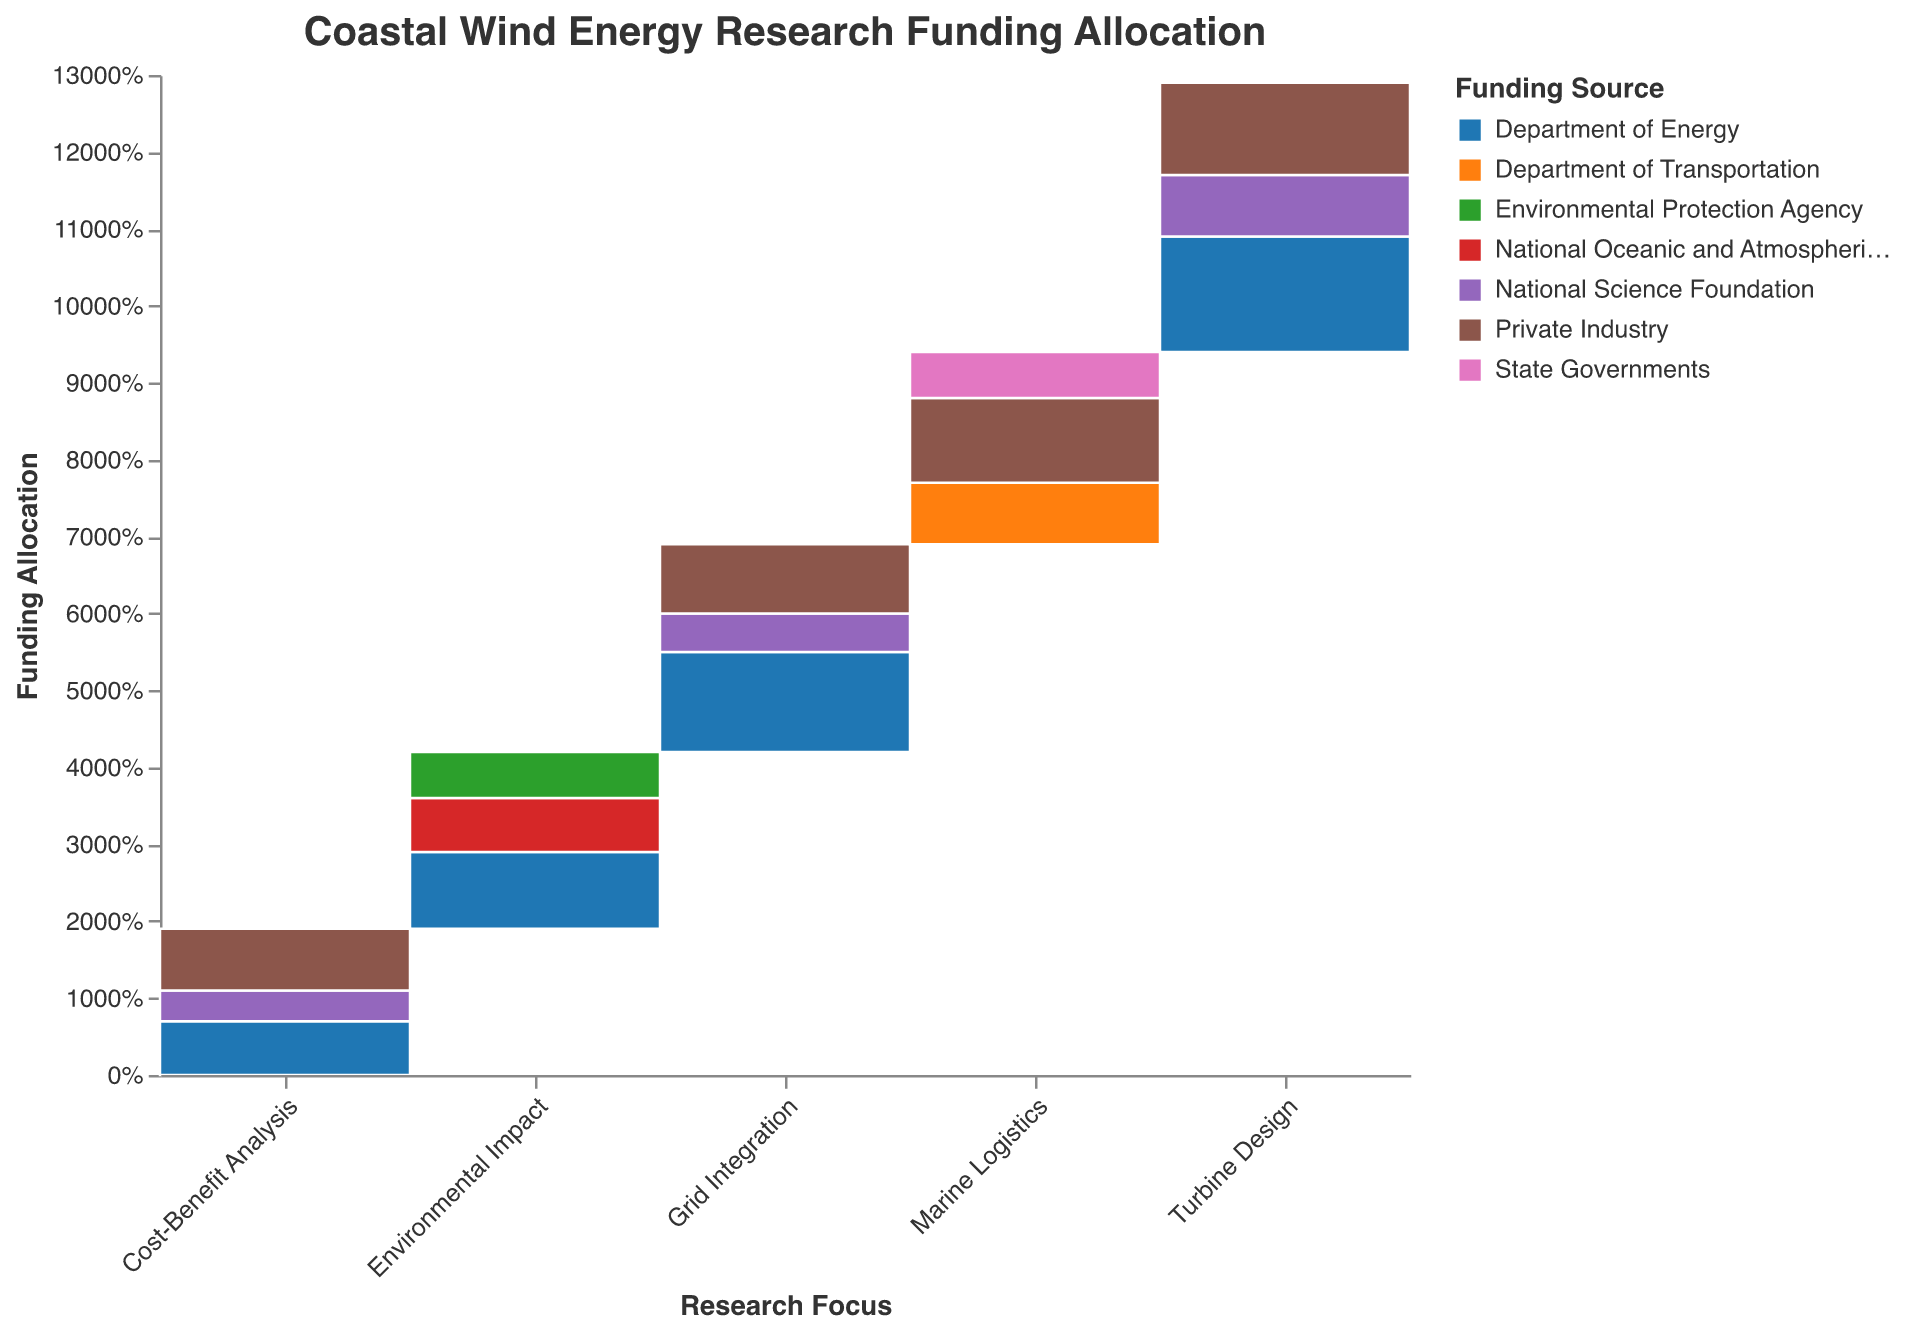What is the title of the plot? The title of the plot is typically located at the top of the visualization and provides a summary of the plot's content. In this case, it reads "Coastal Wind Energy Research Funding Allocation".
Answer: Coastal Wind Energy Research Funding Allocation Which funding source contributes the most to Turbine Design? Look for the largest segment within the "Turbine Design" category. The largest segment is "Department of Energy" with 15 million USD.
Answer: Department of Energy What proportion of the funding for Environmental Impact comes from the National Oceanic and Atmospheric Administration? Identify the segment corresponding to the National Oceanic and Atmospheric Administration in the Environmental Impact category and refer to the tooltip or stacked bar height. It is 7 out of 23 million USD, which is approximately 30.4%.
Answer: 30.4% Compare the total funding for Grid Integration and Marine Logistics. Which has more? Sum the funding amounts for each research focus. Grid Integration totals 27 million USD (13 + 5 + 9), and Marine Logistics totals 25 million USD (8 + 11 + 6). Therefore, Grid Integration has more funding.
Answer: Grid Integration How does the Department of Energy's funding allocation vary across different research focuses? Look for the segments corresponding to the Department of Energy for each research focus and compare their sizes. For example, it is the largest for Turbine Design and also makes substantial contributions to Environmental Impact, Grid Integration, and Cost-Benefit Analysis.
Answer: It varies but is dominant in Turbine Design, significant in Environmental Impact and Grid Integration, and notable in Cost-Benefit Analysis What is the smallest funding allocation within the Cost-Benefit Analysis research focus? Look for the smallest segment within the Cost-Benefit Analysis category. The smallest segment is the National Science Foundation with 4 million USD.
Answer: National Science Foundation Which research focus has the highest total funding allocation from Private Industry? Compare the sum of funding amounts from Private Industry for each research focus. Turbine Design has the highest total from Private Industry, with 12 million USD.
Answer: Turbine Design Calculate the total funding from the National Science Foundation across all research focuses. Sum the National Science Foundation amounts across all categories: 8 (Turbine Design) + 5 (Grid Integration) + 4 (Cost-Benefit Analysis) = 17 million USD.
Answer: 17 million USD Is the funding from Private Industry higher for Marine Logistics or Grid Integration? Compare the segments for Private Industry in both categories. Marine Logistics receives 11 million USD while Grid Integration receives 9 million USD. Therefore, Marine Logistics has higher funding.
Answer: Marine Logistics 